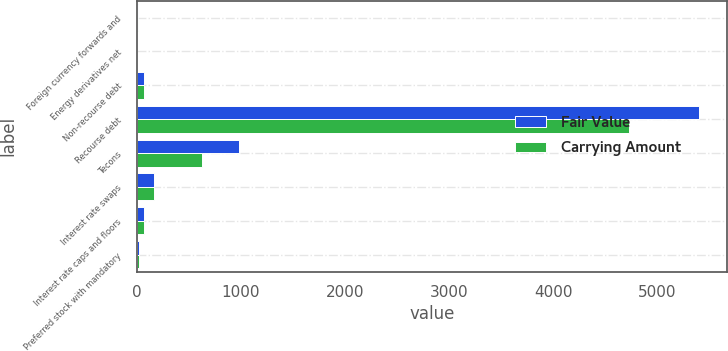Convert chart to OTSL. <chart><loc_0><loc_0><loc_500><loc_500><stacked_bar_chart><ecel><fcel>Foreign currency forwards and<fcel>Energy derivatives net<fcel>Non-recourse debt<fcel>Recourse debt<fcel>Tecons<fcel>Interest rate swaps<fcel>Interest rate caps and floors<fcel>Preferred stock with mandatory<nl><fcel>Fair Value<fcel>14<fcel>7<fcel>72<fcel>5401<fcel>978<fcel>166<fcel>72<fcel>22<nl><fcel>Carrying Amount<fcel>14<fcel>7<fcel>72<fcel>4730<fcel>626<fcel>166<fcel>72<fcel>22<nl></chart> 